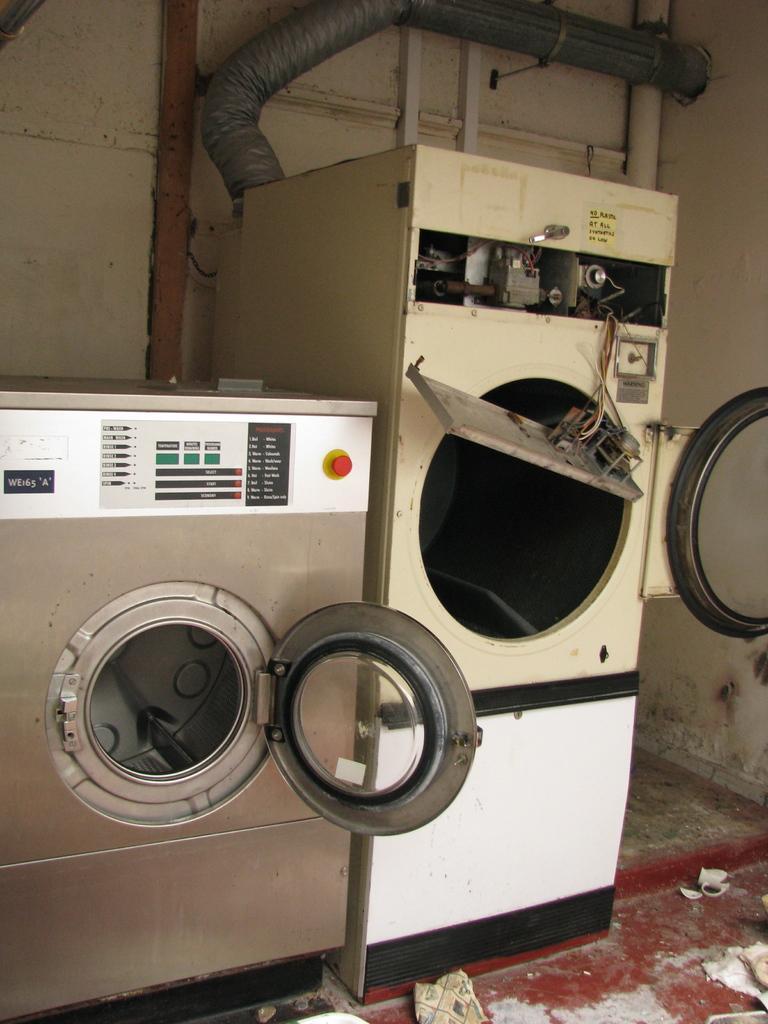How would you summarize this image in a sentence or two? In this image I can see two washing machine and on these machines I can see something is written. 